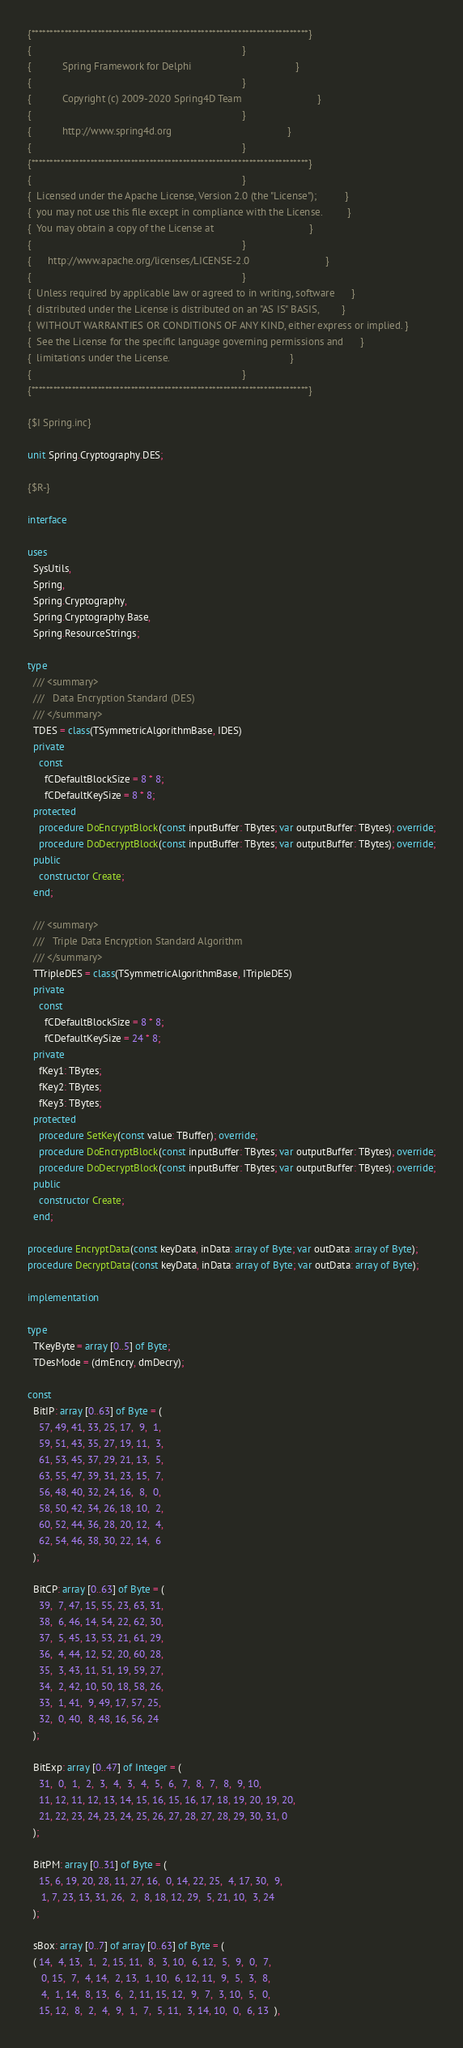Convert code to text. <code><loc_0><loc_0><loc_500><loc_500><_Pascal_>{***************************************************************************}
{                                                                           }
{           Spring Framework for Delphi                                     }
{                                                                           }
{           Copyright (c) 2009-2020 Spring4D Team                           }
{                                                                           }
{           http://www.spring4d.org                                         }
{                                                                           }
{***************************************************************************}
{                                                                           }
{  Licensed under the Apache License, Version 2.0 (the "License");          }
{  you may not use this file except in compliance with the License.         }
{  You may obtain a copy of the License at                                  }
{                                                                           }
{      http://www.apache.org/licenses/LICENSE-2.0                           }
{                                                                           }
{  Unless required by applicable law or agreed to in writing, software      }
{  distributed under the License is distributed on an "AS IS" BASIS,        }
{  WITHOUT WARRANTIES OR CONDITIONS OF ANY KIND, either express or implied. }
{  See the License for the specific language governing permissions and      }
{  limitations under the License.                                           }
{                                                                           }
{***************************************************************************}

{$I Spring.inc}

unit Spring.Cryptography.DES;

{$R-}

interface

uses
  SysUtils,
  Spring,
  Spring.Cryptography,
  Spring.Cryptography.Base,
  Spring.ResourceStrings;

type
  /// <summary>
  ///   Data Encryption Standard (DES)
  /// </summary>
  TDES = class(TSymmetricAlgorithmBase, IDES)
  private
    const
      fCDefaultBlockSize = 8 * 8;
      fCDefaultKeySize = 8 * 8;
  protected
    procedure DoEncryptBlock(const inputBuffer: TBytes; var outputBuffer: TBytes); override;
    procedure DoDecryptBlock(const inputBuffer: TBytes; var outputBuffer: TBytes); override;
  public
    constructor Create;
  end;

  /// <summary>
  ///   Triple Data Encryption Standard Algorithm
  /// </summary>
  TTripleDES = class(TSymmetricAlgorithmBase, ITripleDES)
  private
    const
      fCDefaultBlockSize = 8 * 8;
      fCDefaultKeySize = 24 * 8;
  private
    fKey1: TBytes;
    fKey2: TBytes;
    fKey3: TBytes;
  protected
    procedure SetKey(const value: TBuffer); override;
    procedure DoEncryptBlock(const inputBuffer: TBytes; var outputBuffer: TBytes); override;
    procedure DoDecryptBlock(const inputBuffer: TBytes; var outputBuffer: TBytes); override;
  public
    constructor Create;
  end;

procedure EncryptData(const keyData, inData: array of Byte; var outData: array of Byte);
procedure DecryptData(const keyData, inData: array of Byte; var outData: array of Byte);

implementation

type
  TKeyByte = array [0..5] of Byte;
  TDesMode = (dmEncry, dmDecry);

const
  BitIP: array [0..63] of Byte = (
    57, 49, 41, 33, 25, 17,  9,  1,
    59, 51, 43, 35, 27, 19, 11,  3,
    61, 53, 45, 37, 29, 21, 13,  5,
    63, 55, 47, 39, 31, 23, 15,  7,
    56, 48, 40, 32, 24, 16,  8,  0,
    58, 50, 42, 34, 26, 18, 10,  2,
    60, 52, 44, 36, 28, 20, 12,  4,
    62, 54, 46, 38, 30, 22, 14,  6
  );

  BitCP: array [0..63] of Byte = (
    39,  7, 47, 15, 55, 23, 63, 31,
    38,  6, 46, 14, 54, 22, 62, 30,
    37,  5, 45, 13, 53, 21, 61, 29,
    36,  4, 44, 12, 52, 20, 60, 28,
    35,  3, 43, 11, 51, 19, 59, 27,
    34,  2, 42, 10, 50, 18, 58, 26,
    33,  1, 41,  9, 49, 17, 57, 25,
    32,  0, 40,  8, 48, 16, 56, 24
  );

  BitExp: array [0..47] of Integer = (
    31,  0,  1,  2,  3,  4,  3,  4,  5,  6,  7,  8,  7,  8,  9, 10,
    11, 12, 11, 12, 13, 14, 15, 16, 15, 16, 17, 18, 19, 20, 19, 20,
    21, 22, 23, 24, 23, 24, 25, 26, 27, 28, 27, 28, 29, 30, 31, 0
  );

  BitPM: array [0..31] of Byte = (
    15, 6, 19, 20, 28, 11, 27, 16,  0, 14, 22, 25,  4, 17, 30,  9,
     1, 7, 23, 13, 31, 26,  2,  8, 18, 12, 29,  5, 21, 10,  3, 24
  );

  sBox: array [0..7] of array [0..63] of Byte = (
  ( 14,  4, 13,  1,  2, 15, 11,  8,  3, 10,  6, 12,  5,  9,  0,  7,
     0, 15,  7,  4, 14,  2, 13,  1, 10,  6, 12, 11,  9,  5,  3,  8,
     4,  1, 14,  8, 13,  6,  2, 11, 15, 12,  9,  7,  3, 10,  5,  0,
    15, 12,  8,  2,  4,  9,  1,  7,  5, 11,  3, 14, 10,  0,  6, 13  ),
</code> 